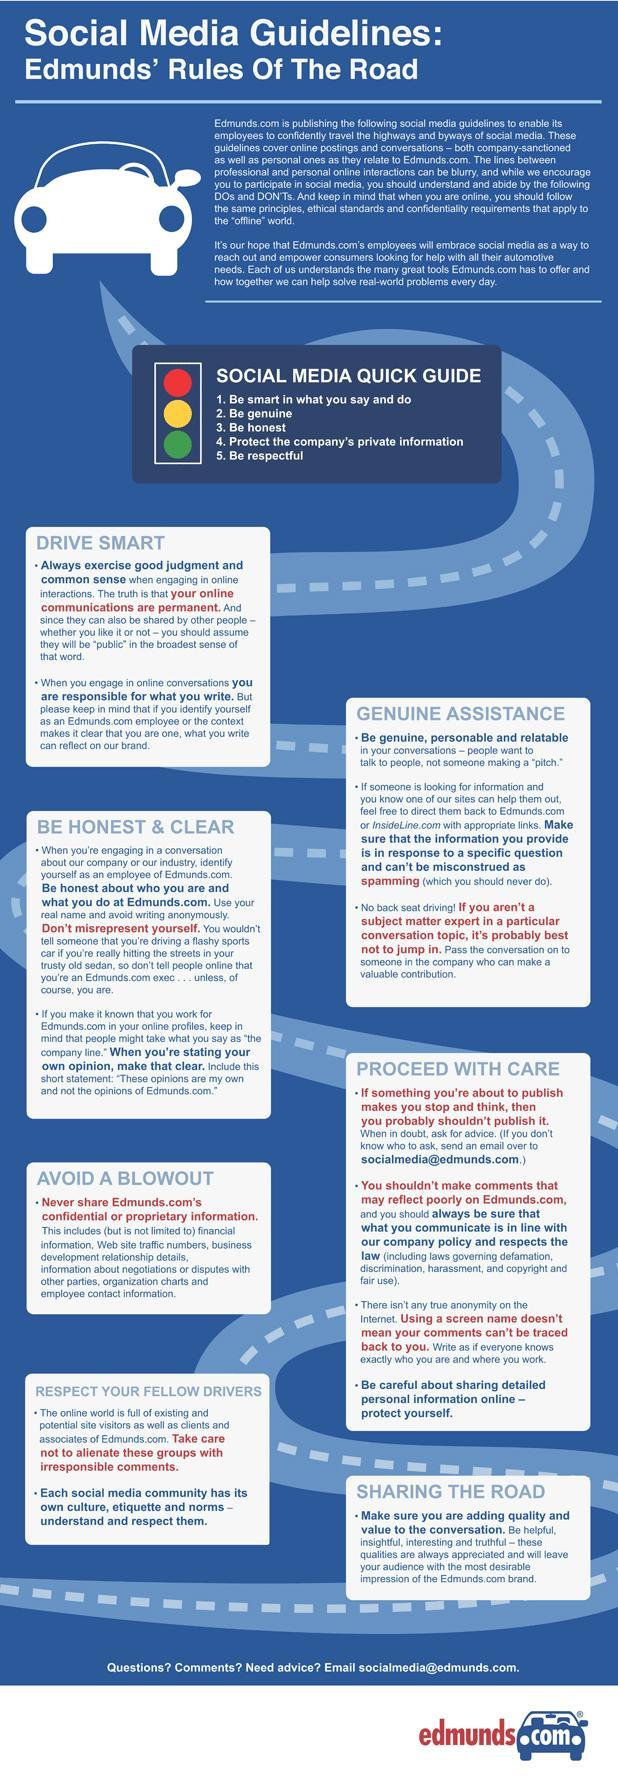How many points are listed under the heading "Genuine Assistance"?
Answer the question with a short phrase. 3 What are the points to kept in mind during the conversation when somebody calls for help? Be genuine, personable and relatable What is the color of the first light in traffic signal- green, yellow, red, orange? red 